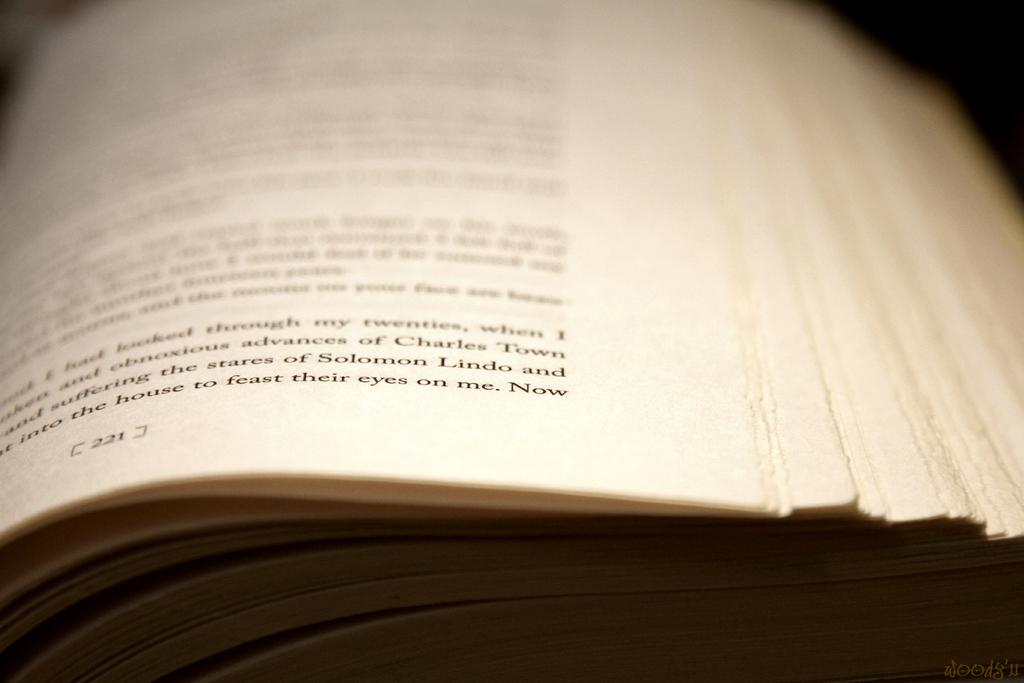<image>
Create a compact narrative representing the image presented. The reader of this book is on page 221. 